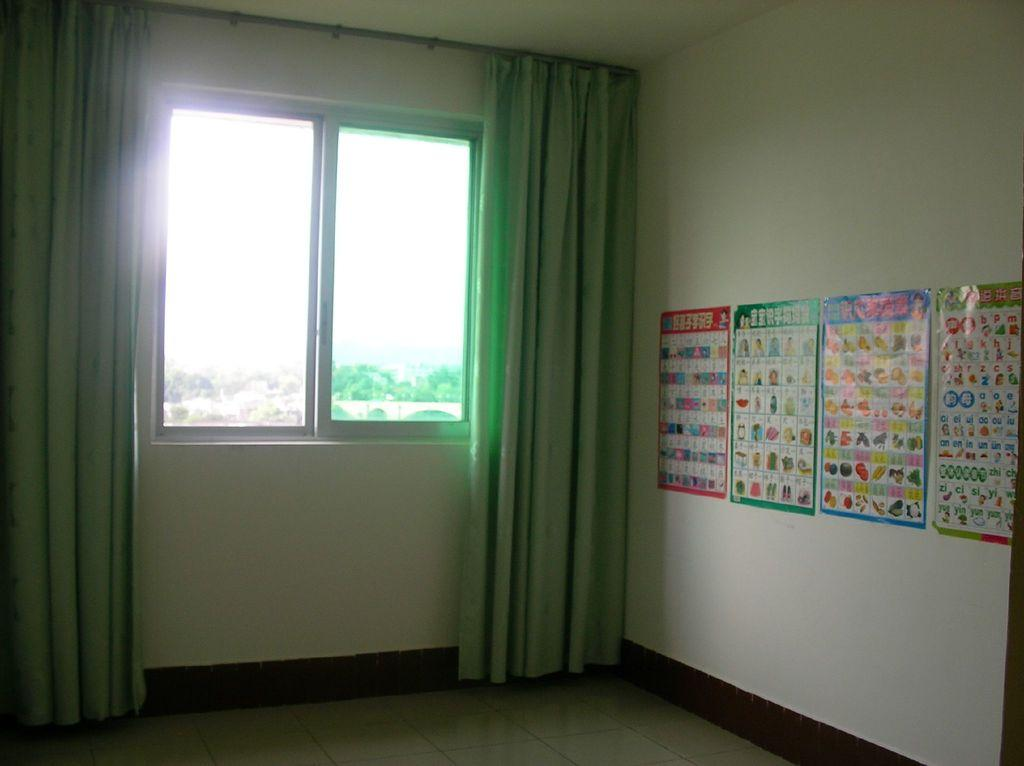What is at the bottom of the image? There is a floor at the bottom of the image. What can be seen on the wall in the image? There are posts on the wall in the image. What type of window treatment is present in the image? There are curtains in the image. What is the purpose of the window in the image? The window allows light to enter the room and provides a view of the outside. What type of dinner is being served in the image? There is no dinner present in the image; it only features a floor, posts, curtains, and a window. Is there a fight happening in the image? There is no fight depicted in the image; it is a peaceful scene with a floor, posts, curtains, and a window. 